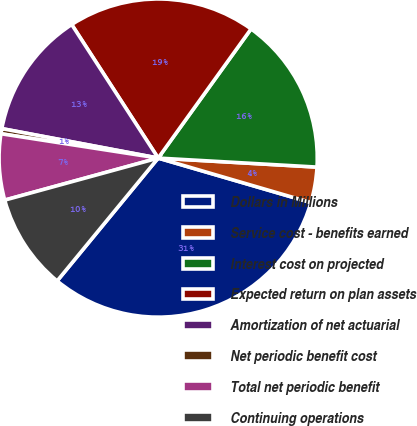Convert chart. <chart><loc_0><loc_0><loc_500><loc_500><pie_chart><fcel>Dollars in Millions<fcel>Service cost - benefits earned<fcel>Interest cost on projected<fcel>Expected return on plan assets<fcel>Amortization of net actuarial<fcel>Net periodic benefit cost<fcel>Total net periodic benefit<fcel>Continuing operations<nl><fcel>31.44%<fcel>3.61%<fcel>15.98%<fcel>19.07%<fcel>12.89%<fcel>0.52%<fcel>6.7%<fcel>9.79%<nl></chart> 